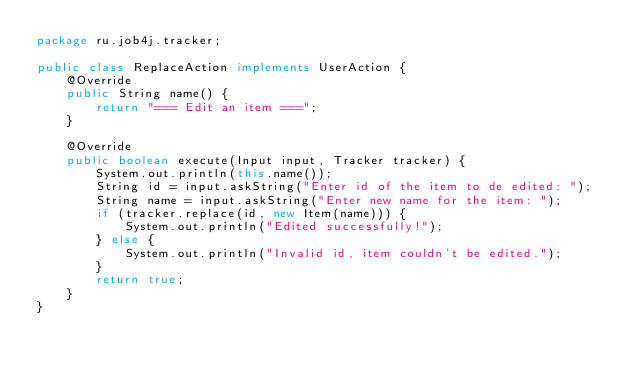Convert code to text. <code><loc_0><loc_0><loc_500><loc_500><_Java_>package ru.job4j.tracker;

public class ReplaceAction implements UserAction {
    @Override
    public String name() {
        return "=== Edit an item ===";
    }

    @Override
    public boolean execute(Input input, Tracker tracker) {
        System.out.println(this.name());
        String id = input.askString("Enter id of the item to de edited: ");
        String name = input.askString("Enter new name for the item: ");
        if (tracker.replace(id, new Item(name))) {
            System.out.println("Edited successfully!");
        } else {
            System.out.println("Invalid id, item couldn't be edited.");
        }
        return true;
    }
}

</code> 